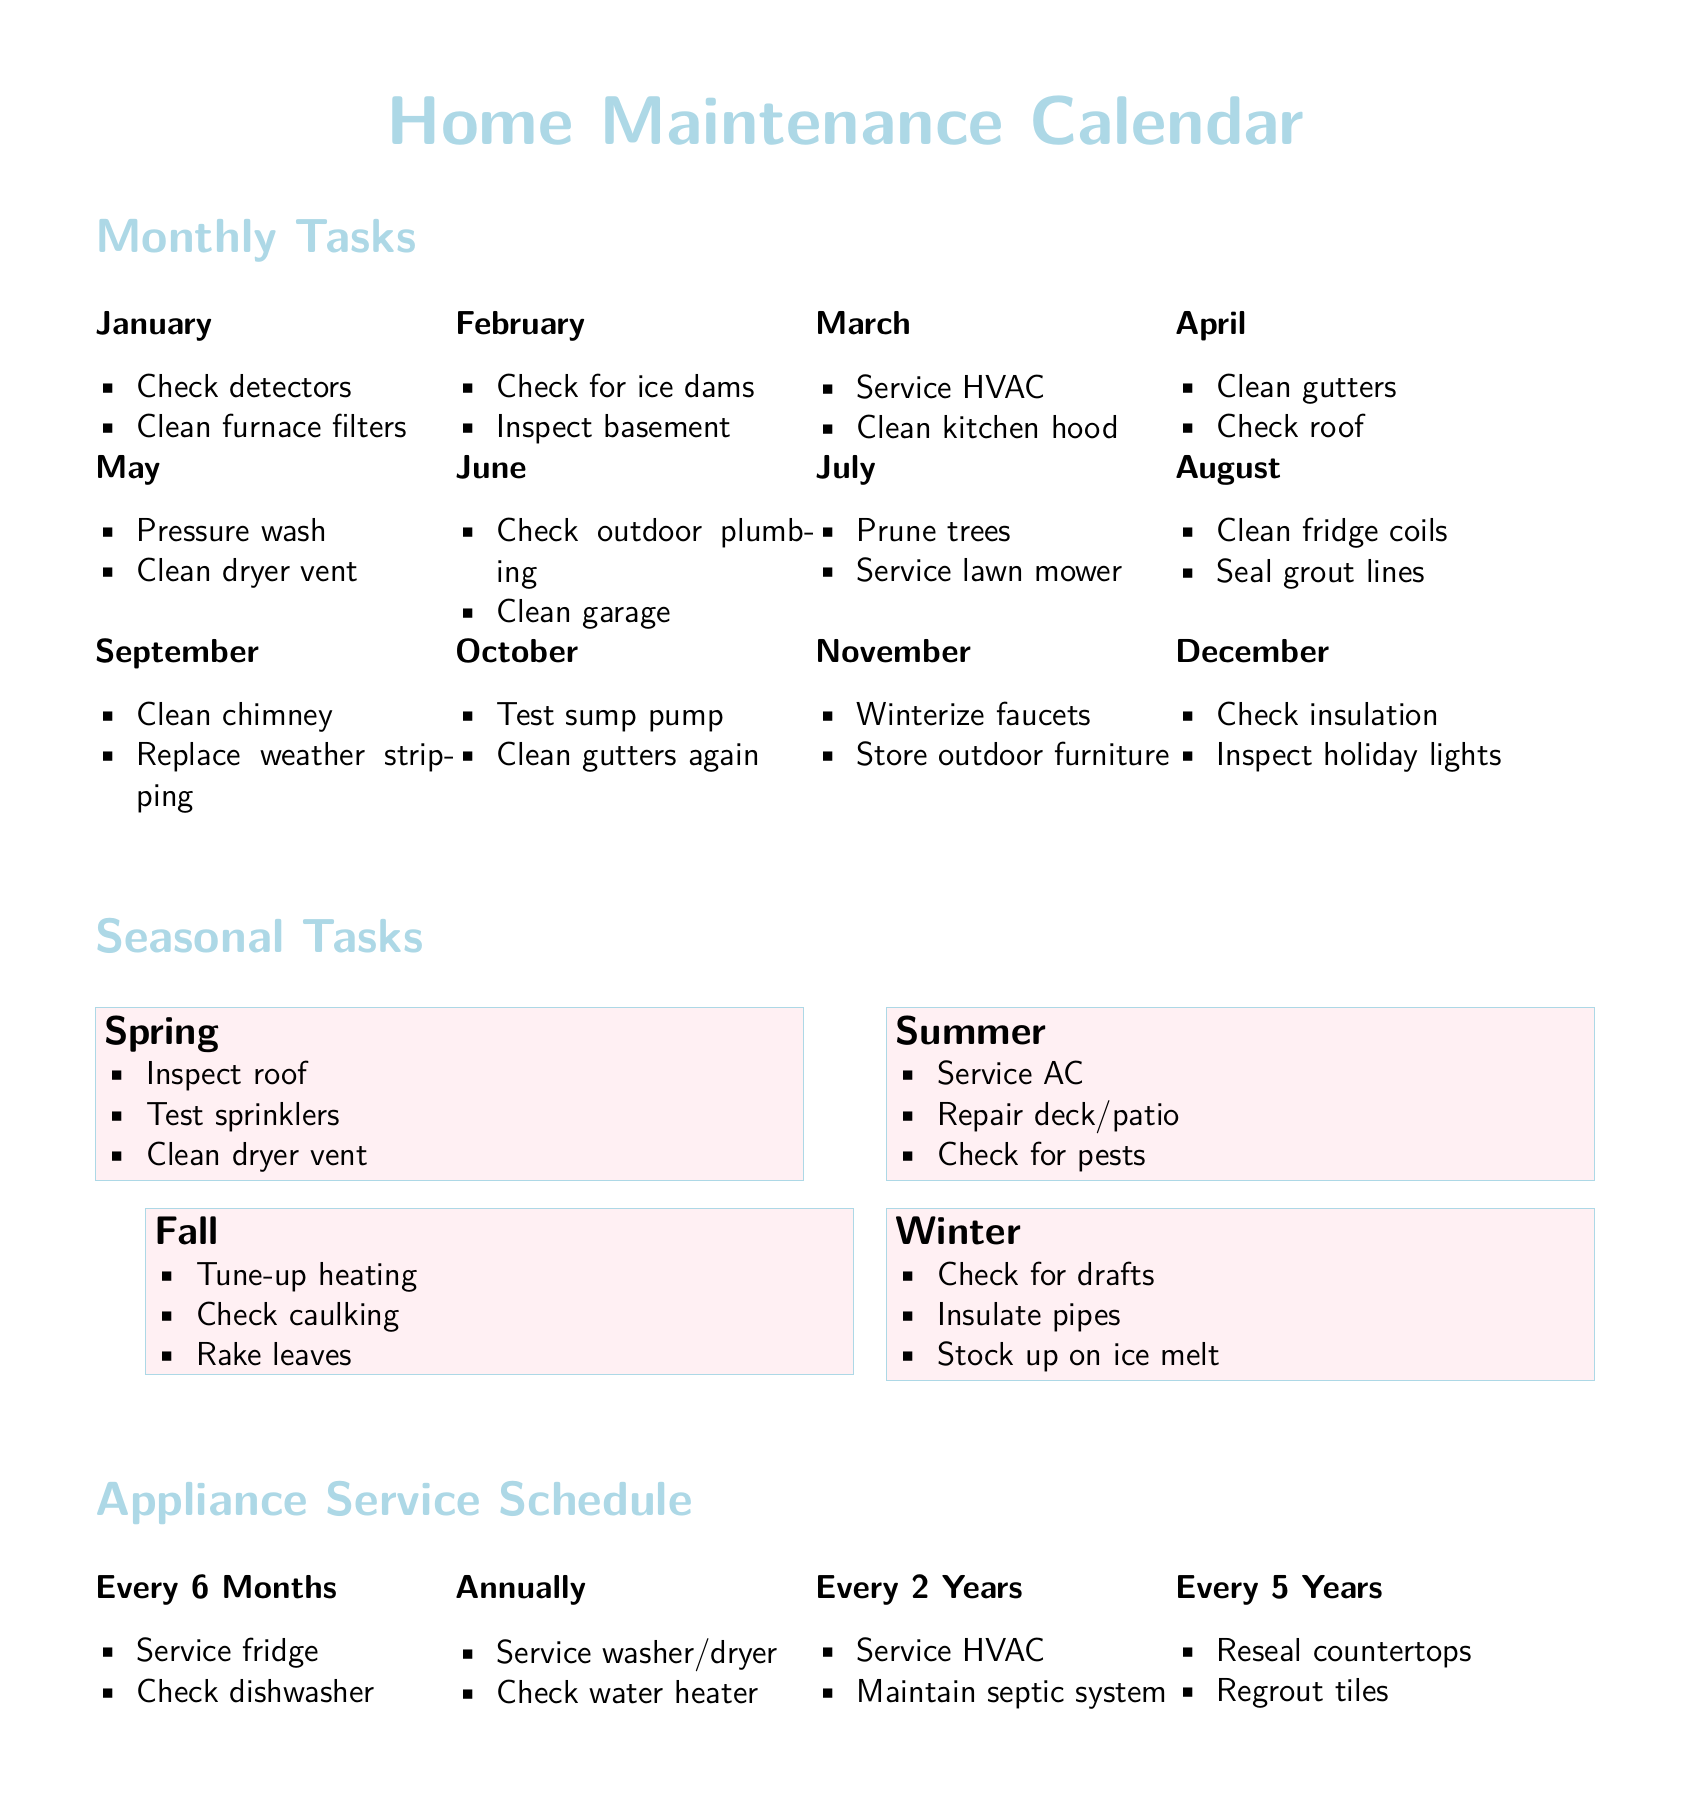What are the monthly tasks for January? The monthly tasks listed for January include checking detectors and cleaning furnace filters.
Answer: Check detectors, Clean furnace filters Which month includes the task to clean gutters again? The task to clean gutters again is scheduled for October.
Answer: October How often should the fridge be serviced? The document states that the fridge should be serviced every 6 months.
Answer: Every 6 Months What seasonal task is recommended for summer? The recommended tasks for summer include servicing the AC.
Answer: Service AC How many tasks are listed under the fall seasonal category? There are three tasks listed under the fall seasonal category.
Answer: 3 What maintenance task is assigned to March? The maintenance tasks for March include servicing HVAC and cleaning the kitchen hood.
Answer: Service HVAC, Clean kitchen hood When should outdoor furniture be stored? Outdoor furniture should be stored in November.
Answer: November What is the first task listed under the winter season? The first task listed under the winter season is to check for drafts.
Answer: Check for drafts 